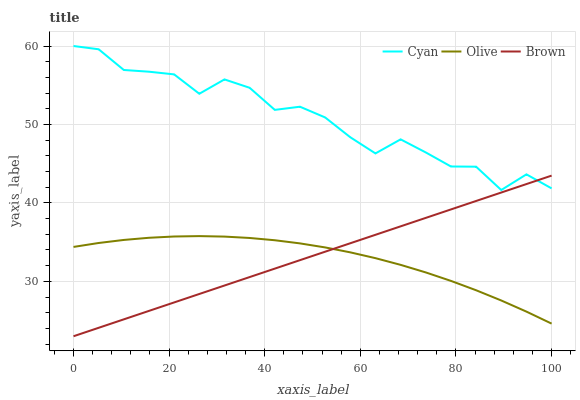Does Olive have the minimum area under the curve?
Answer yes or no. Yes. Does Cyan have the maximum area under the curve?
Answer yes or no. Yes. Does Brown have the minimum area under the curve?
Answer yes or no. No. Does Brown have the maximum area under the curve?
Answer yes or no. No. Is Brown the smoothest?
Answer yes or no. Yes. Is Cyan the roughest?
Answer yes or no. Yes. Is Cyan the smoothest?
Answer yes or no. No. Is Brown the roughest?
Answer yes or no. No. Does Cyan have the lowest value?
Answer yes or no. No. Does Brown have the highest value?
Answer yes or no. No. Is Olive less than Cyan?
Answer yes or no. Yes. Is Cyan greater than Olive?
Answer yes or no. Yes. Does Olive intersect Cyan?
Answer yes or no. No. 